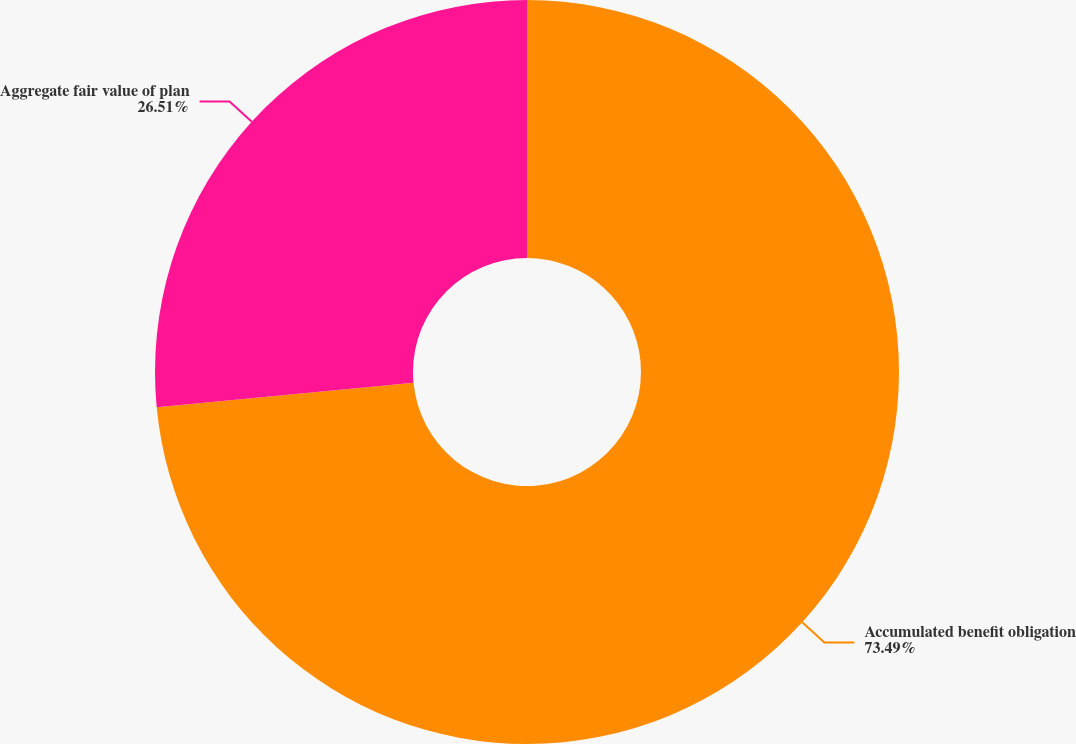Convert chart. <chart><loc_0><loc_0><loc_500><loc_500><pie_chart><fcel>Accumulated benefit obligation<fcel>Aggregate fair value of plan<nl><fcel>73.49%<fcel>26.51%<nl></chart> 